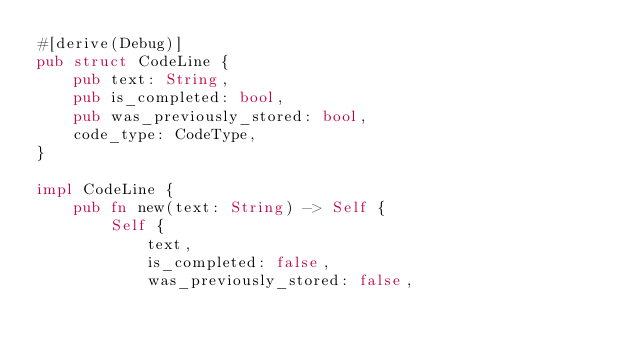Convert code to text. <code><loc_0><loc_0><loc_500><loc_500><_Rust_>#[derive(Debug)]
pub struct CodeLine {
    pub text: String,
    pub is_completed: bool,
    pub was_previously_stored: bool,
    code_type: CodeType,
}

impl CodeLine {
    pub fn new(text: String) -> Self {
        Self {
            text,
            is_completed: false,
            was_previously_stored: false,</code> 